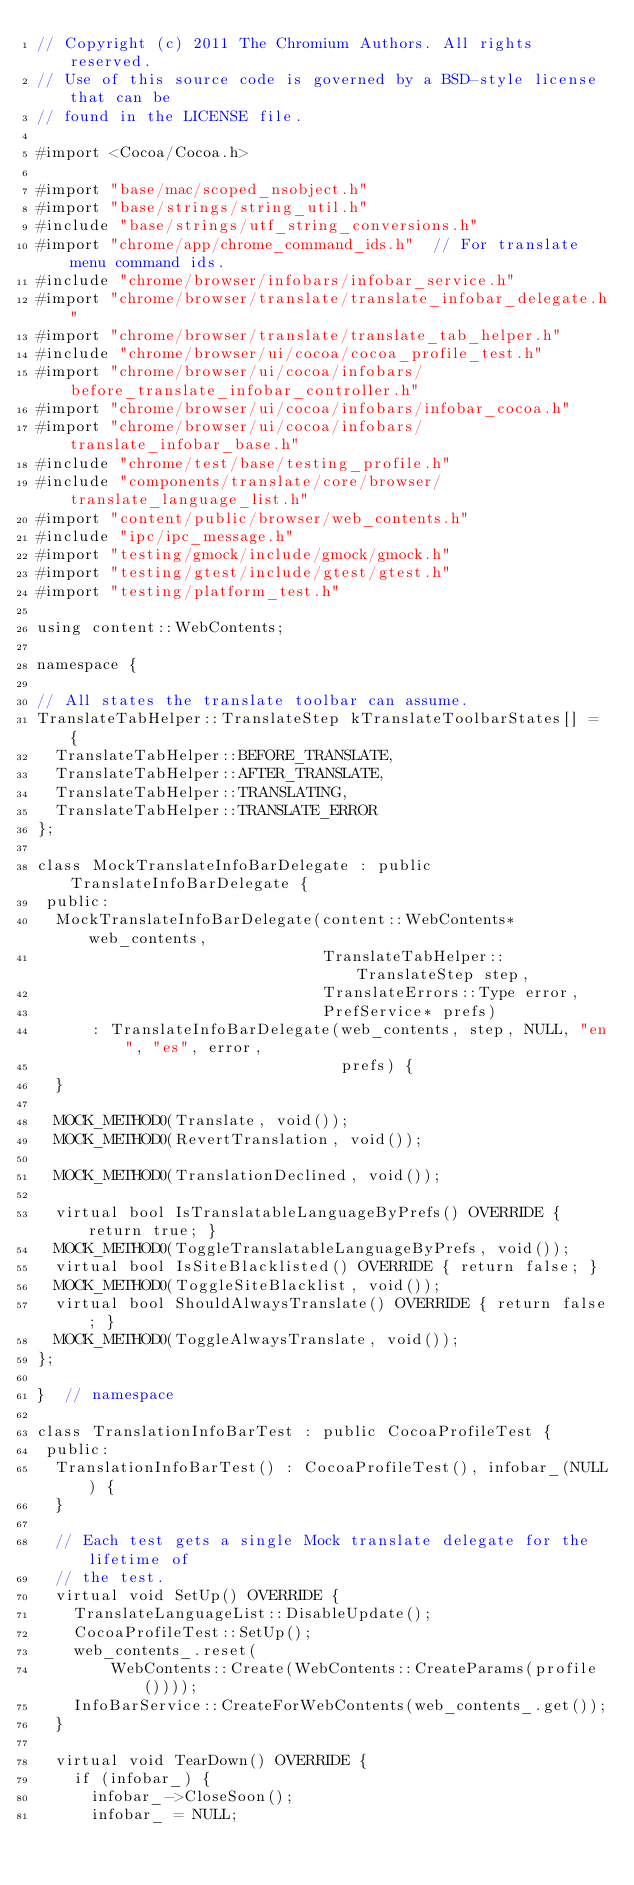Convert code to text. <code><loc_0><loc_0><loc_500><loc_500><_ObjectiveC_>// Copyright (c) 2011 The Chromium Authors. All rights reserved.
// Use of this source code is governed by a BSD-style license that can be
// found in the LICENSE file.

#import <Cocoa/Cocoa.h>

#import "base/mac/scoped_nsobject.h"
#import "base/strings/string_util.h"
#include "base/strings/utf_string_conversions.h"
#import "chrome/app/chrome_command_ids.h"  // For translate menu command ids.
#include "chrome/browser/infobars/infobar_service.h"
#import "chrome/browser/translate/translate_infobar_delegate.h"
#import "chrome/browser/translate/translate_tab_helper.h"
#include "chrome/browser/ui/cocoa/cocoa_profile_test.h"
#import "chrome/browser/ui/cocoa/infobars/before_translate_infobar_controller.h"
#import "chrome/browser/ui/cocoa/infobars/infobar_cocoa.h"
#import "chrome/browser/ui/cocoa/infobars/translate_infobar_base.h"
#include "chrome/test/base/testing_profile.h"
#include "components/translate/core/browser/translate_language_list.h"
#import "content/public/browser/web_contents.h"
#include "ipc/ipc_message.h"
#import "testing/gmock/include/gmock/gmock.h"
#import "testing/gtest/include/gtest/gtest.h"
#import "testing/platform_test.h"

using content::WebContents;

namespace {

// All states the translate toolbar can assume.
TranslateTabHelper::TranslateStep kTranslateToolbarStates[] = {
  TranslateTabHelper::BEFORE_TRANSLATE,
  TranslateTabHelper::AFTER_TRANSLATE,
  TranslateTabHelper::TRANSLATING,
  TranslateTabHelper::TRANSLATE_ERROR
};

class MockTranslateInfoBarDelegate : public TranslateInfoBarDelegate {
 public:
  MockTranslateInfoBarDelegate(content::WebContents* web_contents,
                               TranslateTabHelper::TranslateStep step,
                               TranslateErrors::Type error,
                               PrefService* prefs)
      : TranslateInfoBarDelegate(web_contents, step, NULL, "en", "es", error,
                                 prefs) {
  }

  MOCK_METHOD0(Translate, void());
  MOCK_METHOD0(RevertTranslation, void());

  MOCK_METHOD0(TranslationDeclined, void());

  virtual bool IsTranslatableLanguageByPrefs() OVERRIDE { return true; }
  MOCK_METHOD0(ToggleTranslatableLanguageByPrefs, void());
  virtual bool IsSiteBlacklisted() OVERRIDE { return false; }
  MOCK_METHOD0(ToggleSiteBlacklist, void());
  virtual bool ShouldAlwaysTranslate() OVERRIDE { return false; }
  MOCK_METHOD0(ToggleAlwaysTranslate, void());
};

}  // namespace

class TranslationInfoBarTest : public CocoaProfileTest {
 public:
  TranslationInfoBarTest() : CocoaProfileTest(), infobar_(NULL) {
  }

  // Each test gets a single Mock translate delegate for the lifetime of
  // the test.
  virtual void SetUp() OVERRIDE {
    TranslateLanguageList::DisableUpdate();
    CocoaProfileTest::SetUp();
    web_contents_.reset(
        WebContents::Create(WebContents::CreateParams(profile())));
    InfoBarService::CreateForWebContents(web_contents_.get());
  }

  virtual void TearDown() OVERRIDE {
    if (infobar_) {
      infobar_->CloseSoon();
      infobar_ = NULL;</code> 